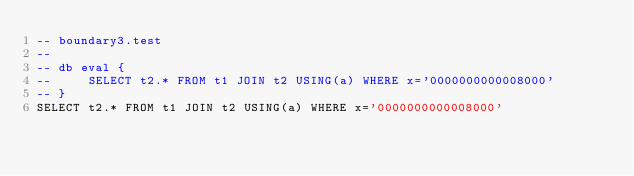Convert code to text. <code><loc_0><loc_0><loc_500><loc_500><_SQL_>-- boundary3.test
-- 
-- db eval {
--     SELECT t2.* FROM t1 JOIN t2 USING(a) WHERE x='0000000000008000'
-- }
SELECT t2.* FROM t1 JOIN t2 USING(a) WHERE x='0000000000008000'</code> 